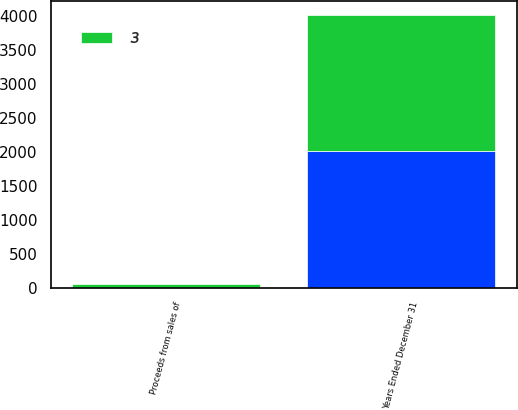<chart> <loc_0><loc_0><loc_500><loc_500><stacked_bar_chart><ecel><fcel>Years Ended December 31<fcel>Proceeds from sales of<nl><fcel>nan<fcel>2010<fcel>1<nl><fcel>3<fcel>2009<fcel>53<nl></chart> 